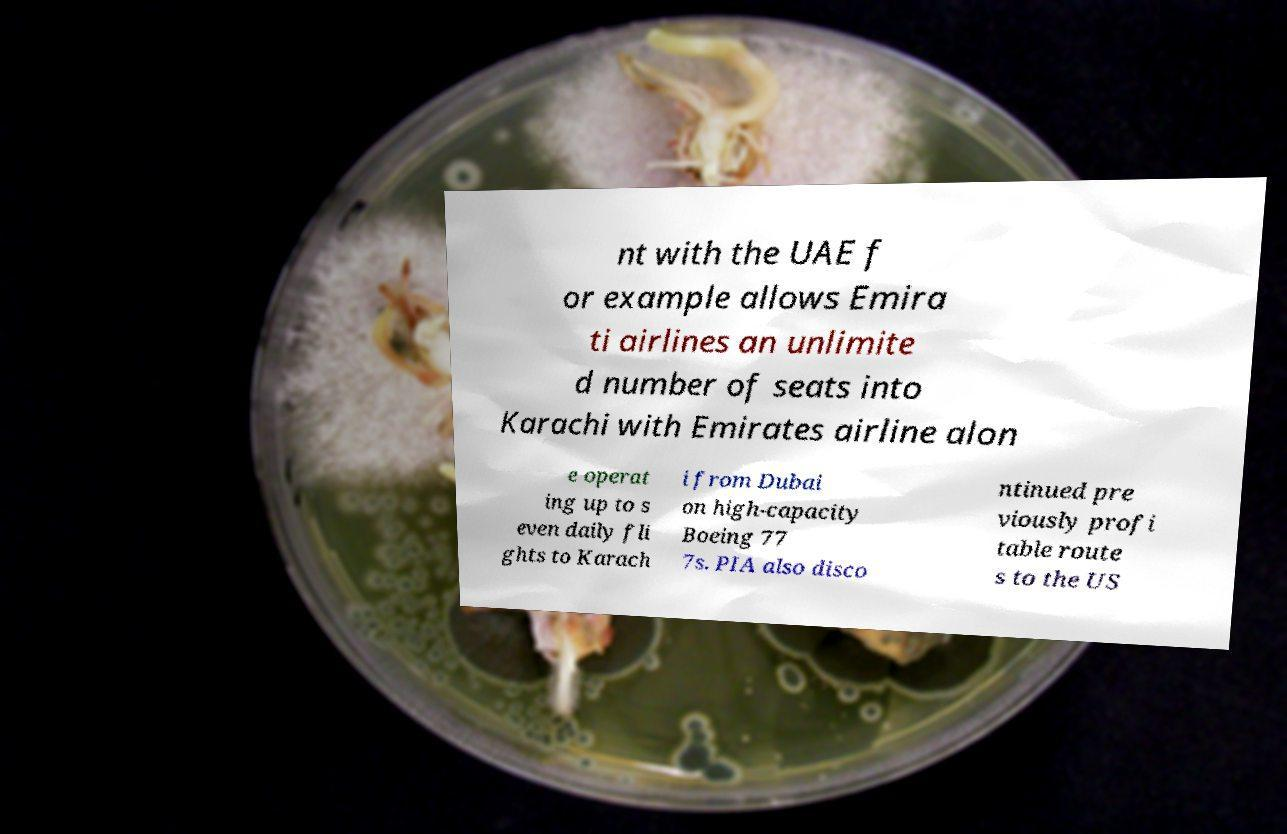Could you assist in decoding the text presented in this image and type it out clearly? nt with the UAE f or example allows Emira ti airlines an unlimite d number of seats into Karachi with Emirates airline alon e operat ing up to s even daily fli ghts to Karach i from Dubai on high-capacity Boeing 77 7s. PIA also disco ntinued pre viously profi table route s to the US 